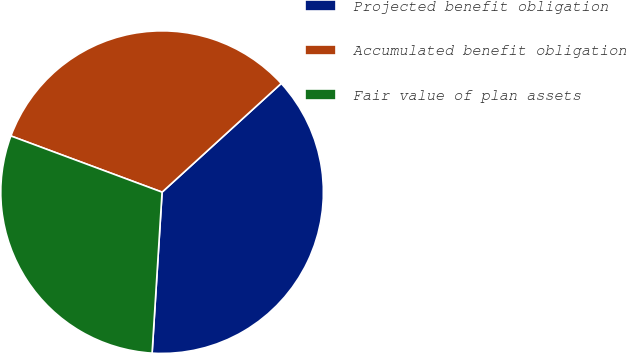<chart> <loc_0><loc_0><loc_500><loc_500><pie_chart><fcel>Projected benefit obligation<fcel>Accumulated benefit obligation<fcel>Fair value of plan assets<nl><fcel>37.76%<fcel>32.57%<fcel>29.68%<nl></chart> 